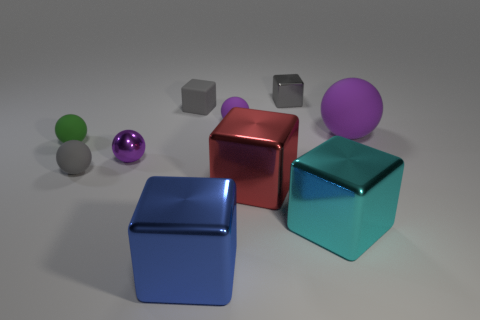Which objects in the image seem to have reflective surfaces? The objects with reflective surfaces include the purple shiny sphere, the red cube, and the two cubes that appear to be in shades of blue. Their surfaces reflect the light and surroundings, giving them a glossier appearance compared to the matte textured objects in the scene. 